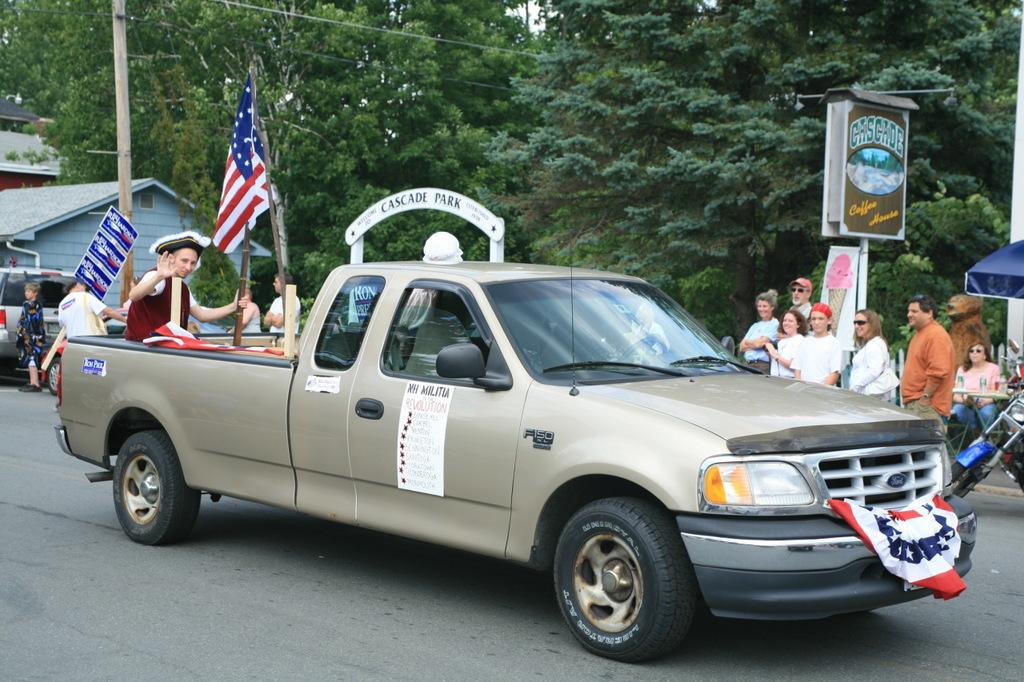What is the main subject of the image? There is a car in the image. What is the guy on the car doing? A guy is sitting on the car. Are there any other people in the image? Yes, there are people standing beside the car. What type of vegetation can be seen in the image? There are plants and trees in the image. What sense is being stimulated by the sleet in the image? There is no mention of sleet in the image, so we cannot determine which sense is being stimulated. --- Facts: 1. There is a person holding a book in the image. 2. The person is sitting on a chair. 3. There is a table in the image. 4. The table has a lamp on it. 5. There is a painting on the wall. Absurd Topics: elephant, ocean, dance Conversation: What is the person in the image holding? The person is holding a book in the image. What is the person's position in the image? The person is sitting on a chair. What furniture is present in the image? There is a table in the image. What object is on the table? The table has a lamp on it. What type of decoration is on the wall? There is a painting on the wall. Reasoning: Let's think step by step in order to produce the conversation. We start by identifying the main subject of the image, which is the person holding a book. Then, we describe the person's position and the furniture present in the image. Next, we mention the object on the table and the type of decoration on the wall. Each question is designed to elicit a specific detail about the image that is known from the provided facts. Absurd Question/Answer: Can you describe the elephant playing in the ocean in the image? There is no elephant or ocean present in the image; it features a person sitting on a chair holding a book, a table with a lamp, and a painting on the wall. 